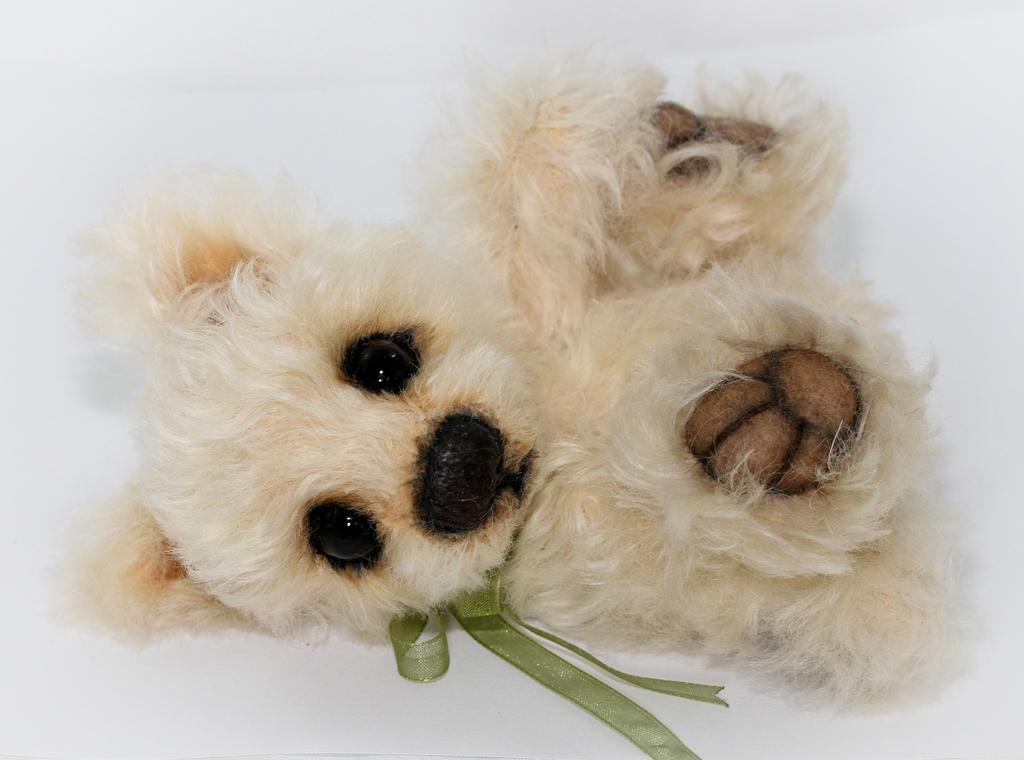Please provide a concise description of this image. In this image we can see one soft toy with a green ribbon around the neck and there is a white background. 